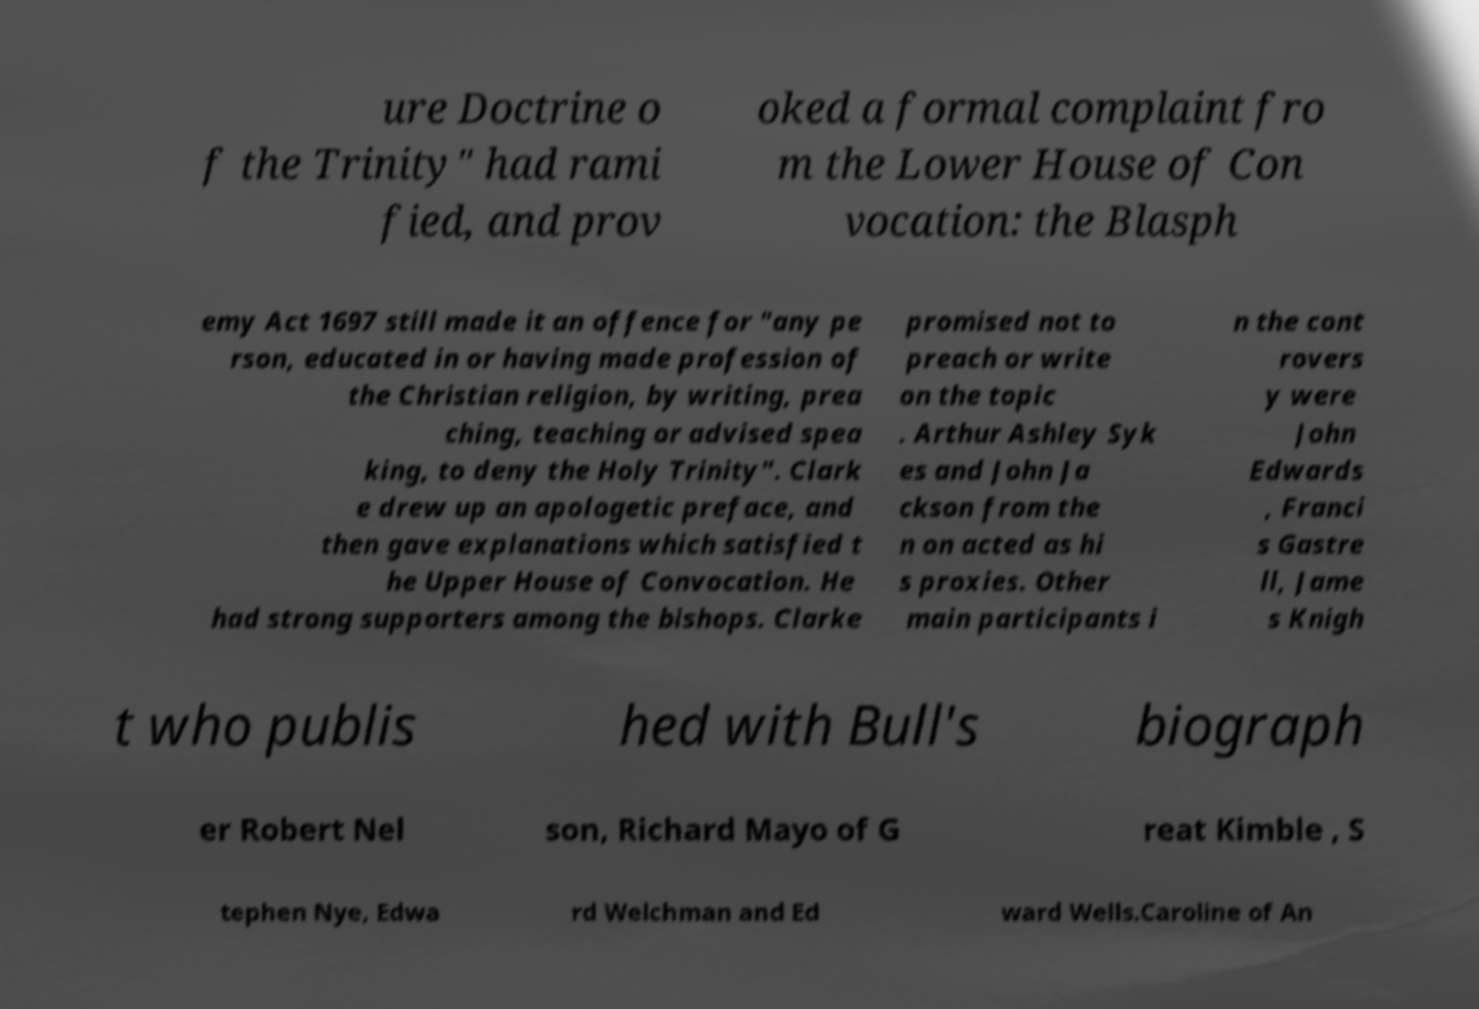Can you read and provide the text displayed in the image?This photo seems to have some interesting text. Can you extract and type it out for me? ure Doctrine o f the Trinity" had rami fied, and prov oked a formal complaint fro m the Lower House of Con vocation: the Blasph emy Act 1697 still made it an offence for "any pe rson, educated in or having made profession of the Christian religion, by writing, prea ching, teaching or advised spea king, to deny the Holy Trinity". Clark e drew up an apologetic preface, and then gave explanations which satisfied t he Upper House of Convocation. He had strong supporters among the bishops. Clarke promised not to preach or write on the topic . Arthur Ashley Syk es and John Ja ckson from the n on acted as hi s proxies. Other main participants i n the cont rovers y were John Edwards , Franci s Gastre ll, Jame s Knigh t who publis hed with Bull's biograph er Robert Nel son, Richard Mayo of G reat Kimble , S tephen Nye, Edwa rd Welchman and Ed ward Wells.Caroline of An 